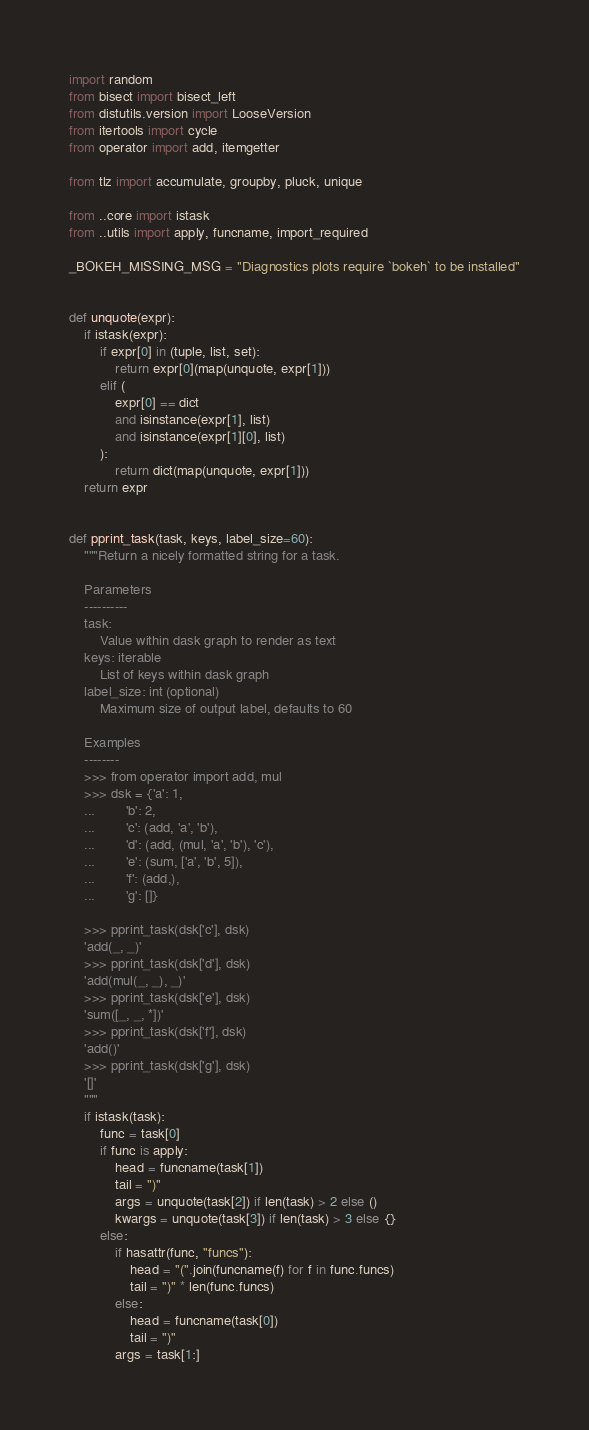<code> <loc_0><loc_0><loc_500><loc_500><_Python_>import random
from bisect import bisect_left
from distutils.version import LooseVersion
from itertools import cycle
from operator import add, itemgetter

from tlz import accumulate, groupby, pluck, unique

from ..core import istask
from ..utils import apply, funcname, import_required

_BOKEH_MISSING_MSG = "Diagnostics plots require `bokeh` to be installed"


def unquote(expr):
    if istask(expr):
        if expr[0] in (tuple, list, set):
            return expr[0](map(unquote, expr[1]))
        elif (
            expr[0] == dict
            and isinstance(expr[1], list)
            and isinstance(expr[1][0], list)
        ):
            return dict(map(unquote, expr[1]))
    return expr


def pprint_task(task, keys, label_size=60):
    """Return a nicely formatted string for a task.

    Parameters
    ----------
    task:
        Value within dask graph to render as text
    keys: iterable
        List of keys within dask graph
    label_size: int (optional)
        Maximum size of output label, defaults to 60

    Examples
    --------
    >>> from operator import add, mul
    >>> dsk = {'a': 1,
    ...        'b': 2,
    ...        'c': (add, 'a', 'b'),
    ...        'd': (add, (mul, 'a', 'b'), 'c'),
    ...        'e': (sum, ['a', 'b', 5]),
    ...        'f': (add,),
    ...        'g': []}

    >>> pprint_task(dsk['c'], dsk)
    'add(_, _)'
    >>> pprint_task(dsk['d'], dsk)
    'add(mul(_, _), _)'
    >>> pprint_task(dsk['e'], dsk)
    'sum([_, _, *])'
    >>> pprint_task(dsk['f'], dsk)
    'add()'
    >>> pprint_task(dsk['g'], dsk)
    '[]'
    """
    if istask(task):
        func = task[0]
        if func is apply:
            head = funcname(task[1])
            tail = ")"
            args = unquote(task[2]) if len(task) > 2 else ()
            kwargs = unquote(task[3]) if len(task) > 3 else {}
        else:
            if hasattr(func, "funcs"):
                head = "(".join(funcname(f) for f in func.funcs)
                tail = ")" * len(func.funcs)
            else:
                head = funcname(task[0])
                tail = ")"
            args = task[1:]</code> 